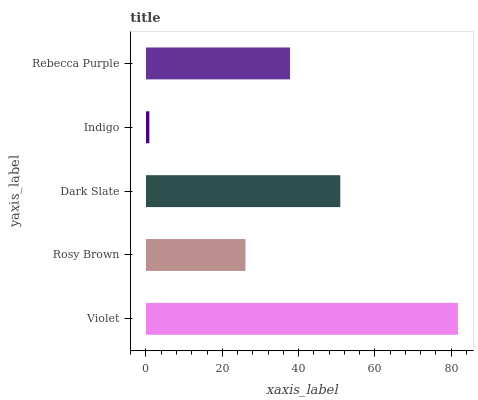Is Indigo the minimum?
Answer yes or no. Yes. Is Violet the maximum?
Answer yes or no. Yes. Is Rosy Brown the minimum?
Answer yes or no. No. Is Rosy Brown the maximum?
Answer yes or no. No. Is Violet greater than Rosy Brown?
Answer yes or no. Yes. Is Rosy Brown less than Violet?
Answer yes or no. Yes. Is Rosy Brown greater than Violet?
Answer yes or no. No. Is Violet less than Rosy Brown?
Answer yes or no. No. Is Rebecca Purple the high median?
Answer yes or no. Yes. Is Rebecca Purple the low median?
Answer yes or no. Yes. Is Violet the high median?
Answer yes or no. No. Is Indigo the low median?
Answer yes or no. No. 